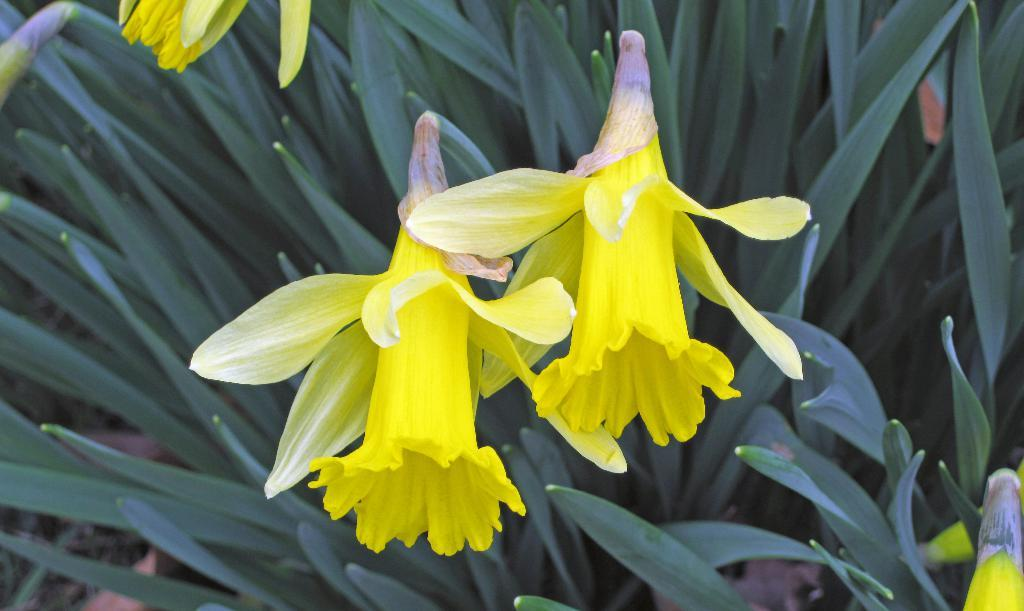What color are the leaves in the image? The leaves in the image are dark green. What type of flowers can be seen in the image? There are yellow flowers in the image. What arithmetic problem is being solved in the image? There is no arithmetic problem present in the image; it features leaves and yellow flowers. Where can you buy the leaves and flowers shown in the image? The image does not depict a shop or any indication of where the leaves and flowers can be purchased. 